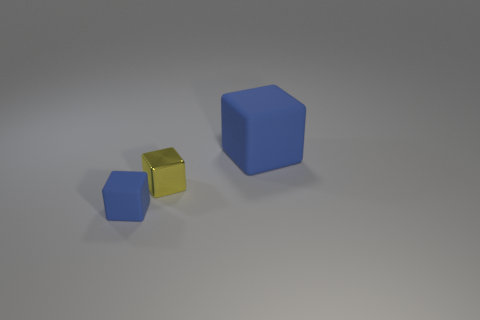Subtract all matte cubes. How many cubes are left? 1 Add 2 tiny metallic objects. How many objects exist? 5 Subtract 1 blocks. How many blocks are left? 2 Subtract all yellow blocks. How many blocks are left? 2 Subtract all blue blocks. Subtract all purple cylinders. How many blocks are left? 1 Subtract all green balls. How many purple cubes are left? 0 Subtract all blue matte objects. Subtract all yellow rubber cubes. How many objects are left? 1 Add 1 large blue matte blocks. How many large blue matte blocks are left? 2 Add 2 gray rubber cubes. How many gray rubber cubes exist? 2 Subtract 0 green cylinders. How many objects are left? 3 